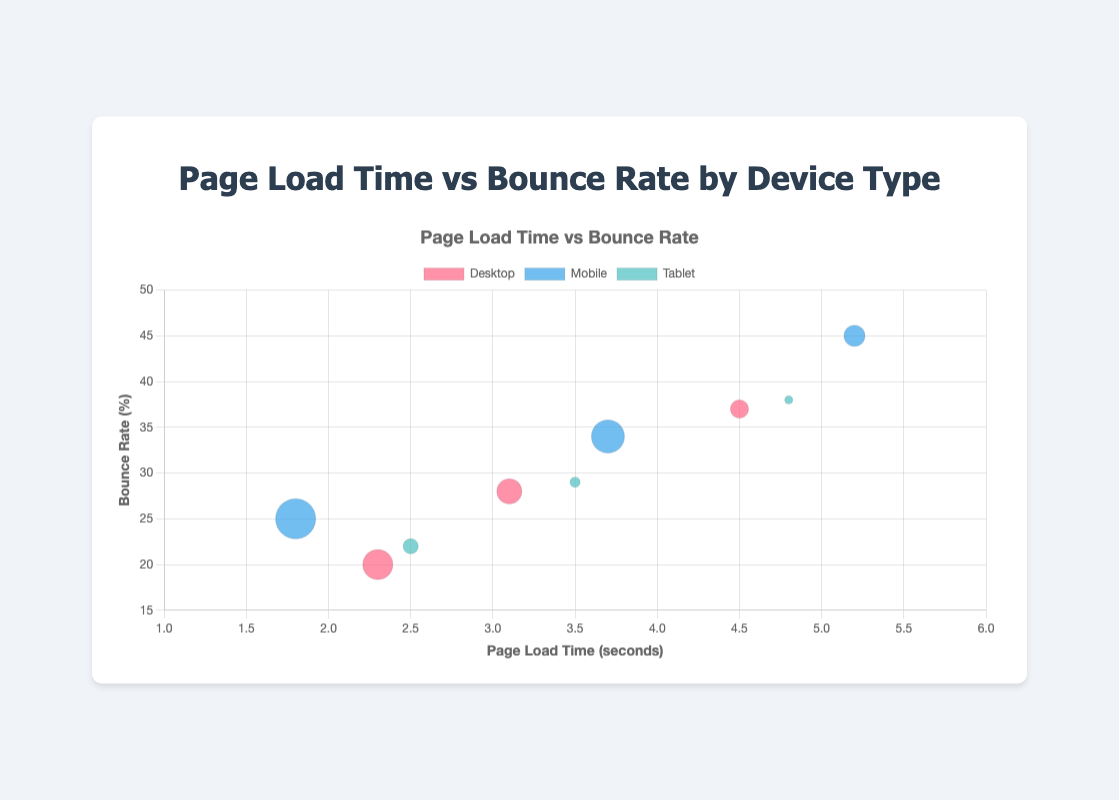What is the title of the chart? The title of the chart is displayed at the top in a larger font. It reads, "Page Load Time vs Bounce Rate by Device Type."
Answer: Page Load Time vs Bounce Rate by Device Type How many data points are there for the 'Mobile' device type? There are three bubbles for the Mobile device type on the chart, each representing a data point with unique x, y, and r values.
Answer: 3 Which device type has the highest bounce rate, and what is the value? To determine the highest bounce rate, check the y-axis values. The point with the highest y value among all devices is from the Mobile device type at (5.2, 45). Thus, the highest bounce rate is 45 for Mobile.
Answer: Mobile, 45 What is the average page load time for the 'Desktop' device type? Sum the page load times for the Desktop device type (2.3 + 3.1 + 4.5) and divide by the number of points (3). So, (2.3 + 3.1 + 4.5) / 3 = 9.9 / 3 = 3.3.
Answer: 3.3 Compare the bounce rates of Mobile and Tablet devices. Which one has a higher average? Calculate the average bounce rates for Mobile (25, 34, 45) and Tablet (22, 29, 38). Mobile: (25 + 34 + 45) / 3 = 104 / 3 ≈ 34.67. Tablet: (22 + 29 + 38) / 3 = 89 / 3 ≈ 29.67. Mobile has a higher average bounce rate.
Answer: Mobile What is the page load time for the data point with the largest bubble in the 'Desktop' category? The largest bubble in the 'Desktop' category corresponds to the largest r value (15). This is at the point (2.3, 20). So, the page load time is 2.3 seconds.
Answer: 2.3 seconds Which device type has the smallest bubble size on the chart? The smallest bubble corresponds to the smallest r value (4), which is found in the Tablet device category at point (4.8, 38).
Answer: Tablet Is there a trend between page load time and bounce rate across different device types? Observing the chart, as the page load time increases, the bounce rate tends to increase across all device types. Thus, there is a positive trend indicating higher page load time results in a higher bounce rate.
Answer: Yes 